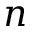Convert formula to latex. <formula><loc_0><loc_0><loc_500><loc_500>n</formula> 